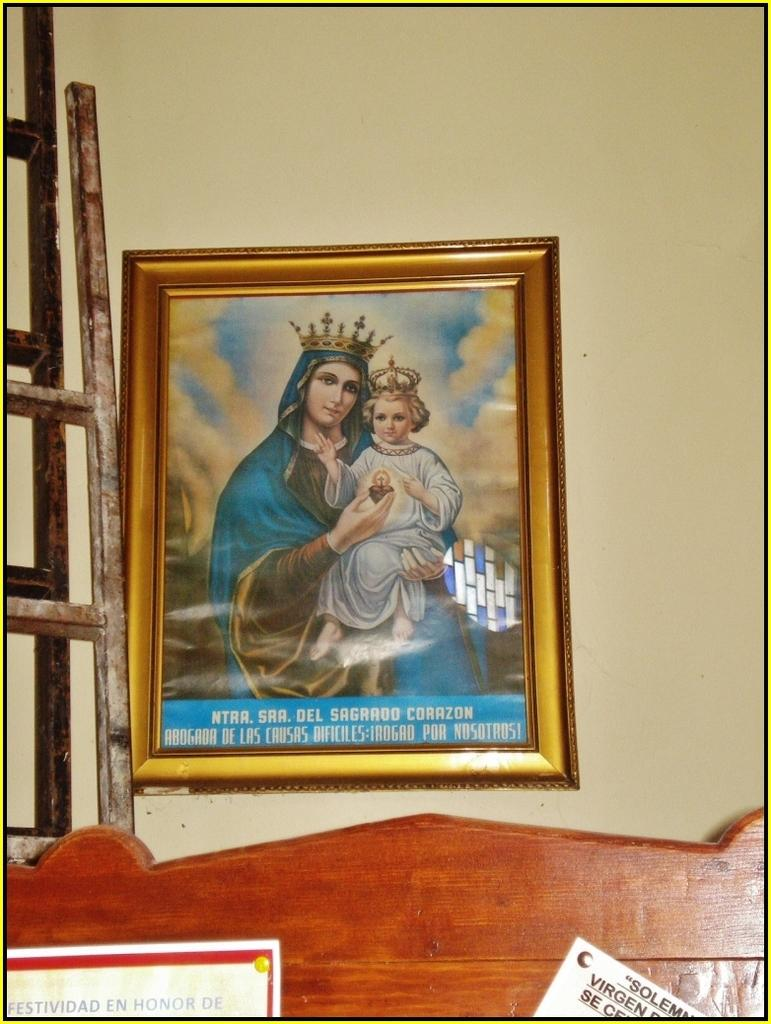Provide a one-sentence caption for the provided image. Painting of a woman holding a child with the words "NTAA. SAA. Del Sagrado Corazon near the bottom. 